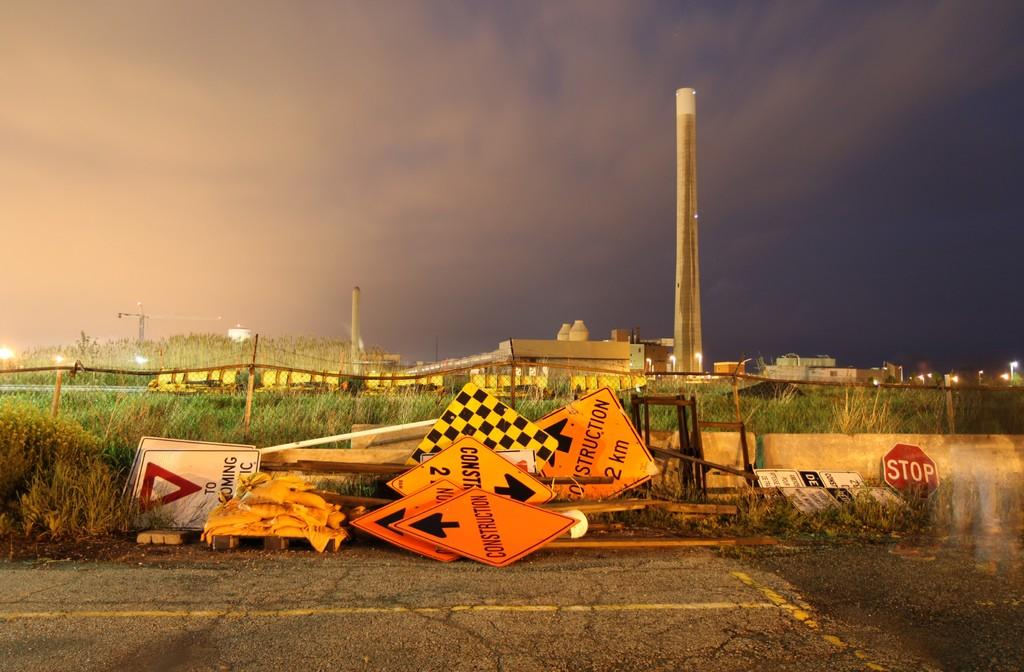<image>
Describe the image concisely. Bunch of construction signs on the side of a road. 